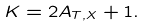Convert formula to latex. <formula><loc_0><loc_0><loc_500><loc_500>K = 2 A _ { T , X } + 1 .</formula> 